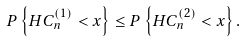<formula> <loc_0><loc_0><loc_500><loc_500>P \left \{ H C _ { n } ^ { ( 1 ) } < x \right \} \leq P \left \{ H C _ { n } ^ { ( 2 ) } < x \right \} .</formula> 